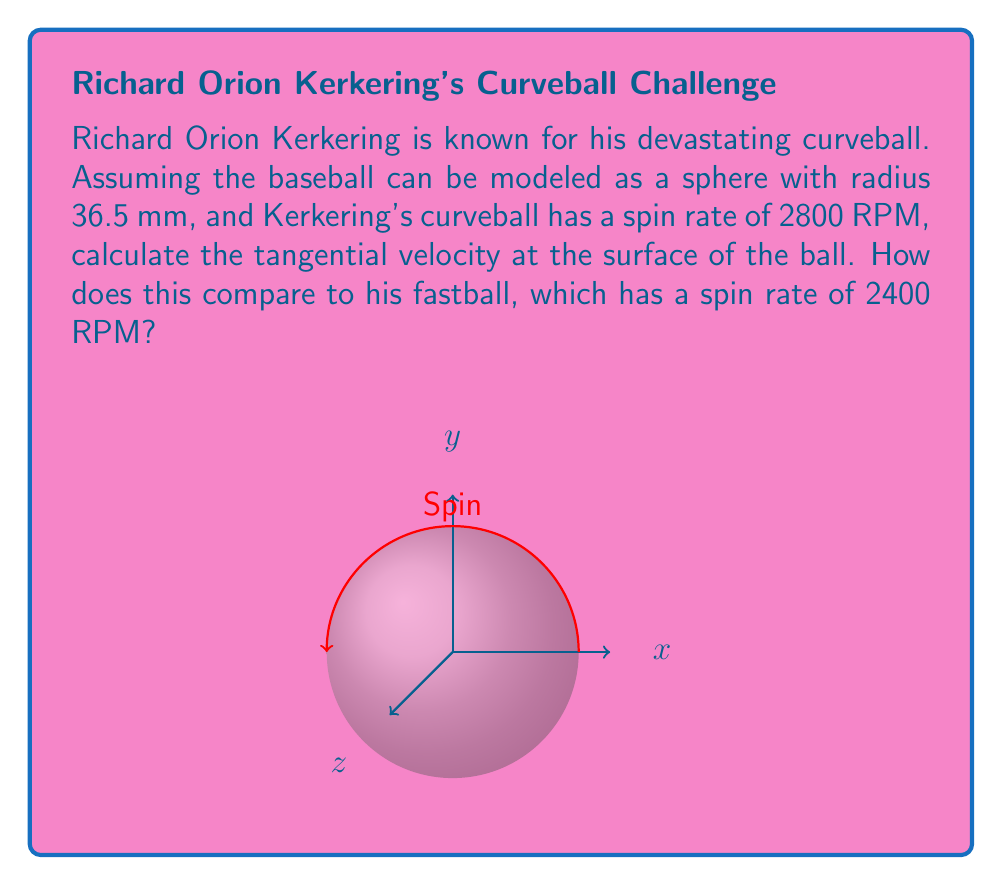Provide a solution to this math problem. Let's approach this step-by-step:

1) The tangent bundle of a sphere represents all possible tangent vectors at every point on the sphere. In this case, we're interested in the tangential velocity at the surface, which is a vector in the tangent space at each point.

2) The tangential velocity $v$ is related to the angular velocity $\omega$ and the radius $r$ by the equation:

   $$v = \omega r$$

3) We need to convert the spin rate from RPM (revolutions per minute) to radians per second:

   $$\omega = 2\pi \cdot \frac{\text{RPM}}{60}$$

4) For the curveball:
   $$\omega_{\text{curve}} = 2\pi \cdot \frac{2800}{60} = \frac{280\pi}{3} \approx 293.22 \text{ rad/s}$$

5) The radius is 36.5 mm = 0.0365 m

6) Therefore, the tangential velocity for the curveball is:
   $$v_{\text{curve}} = \omega_{\text{curve}} r = \frac{280\pi}{3} \cdot 0.0365 \approx 10.70 \text{ m/s}$$

7) For the fastball:
   $$\omega_{\text{fast}} = 2\pi \cdot \frac{2400}{60} = 80\pi \approx 251.33 \text{ rad/s}$$
   $$v_{\text{fast}} = \omega_{\text{fast}} r = 80\pi \cdot 0.0365 \approx 9.17 \text{ m/s}$$

8) Comparing the two:
   The curveball's tangential velocity is about 16.7% higher than the fastball's.
Answer: Curveball: 10.70 m/s, Fastball: 9.17 m/s. Curveball is 16.7% faster. 